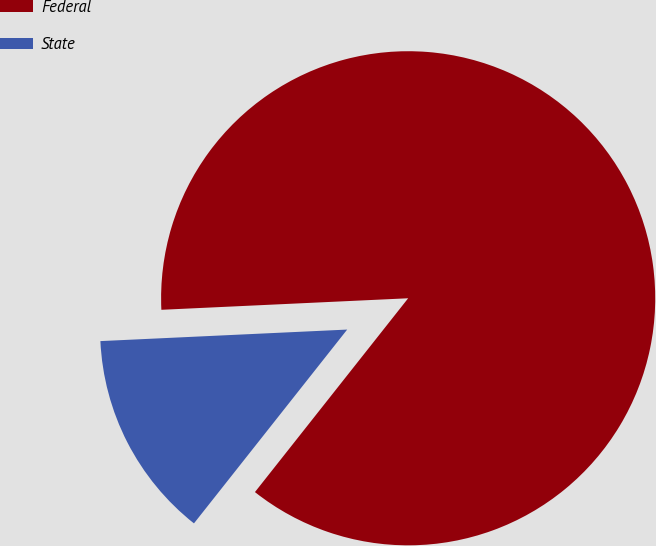Convert chart. <chart><loc_0><loc_0><loc_500><loc_500><pie_chart><fcel>Federal<fcel>State<nl><fcel>86.39%<fcel>13.61%<nl></chart> 